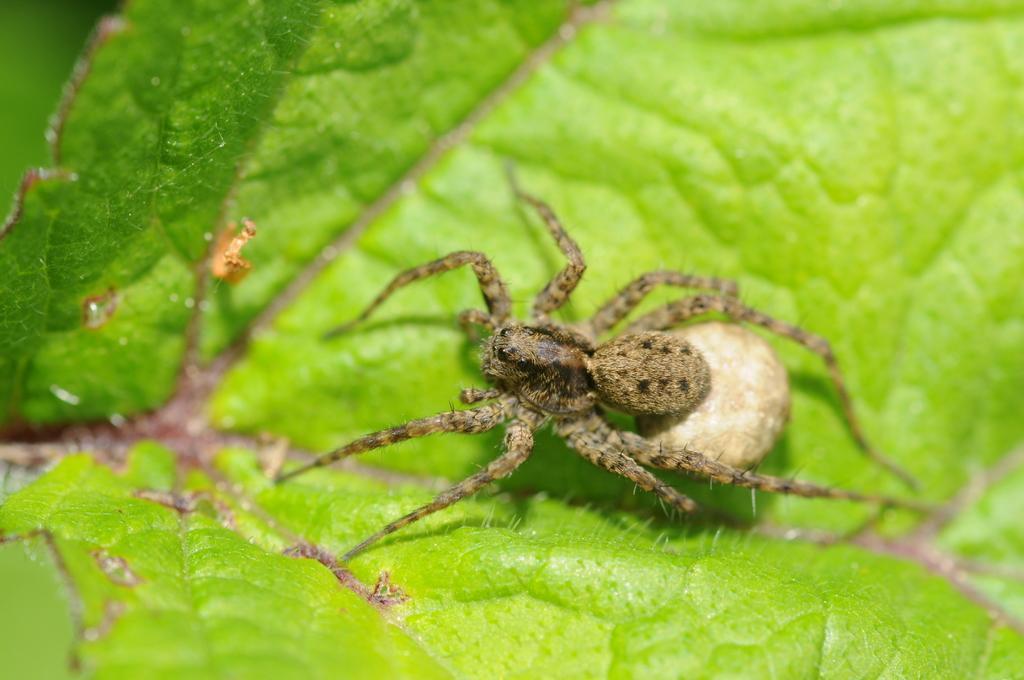Please provide a concise description of this image. In the image on the green leaf there is a spider. 